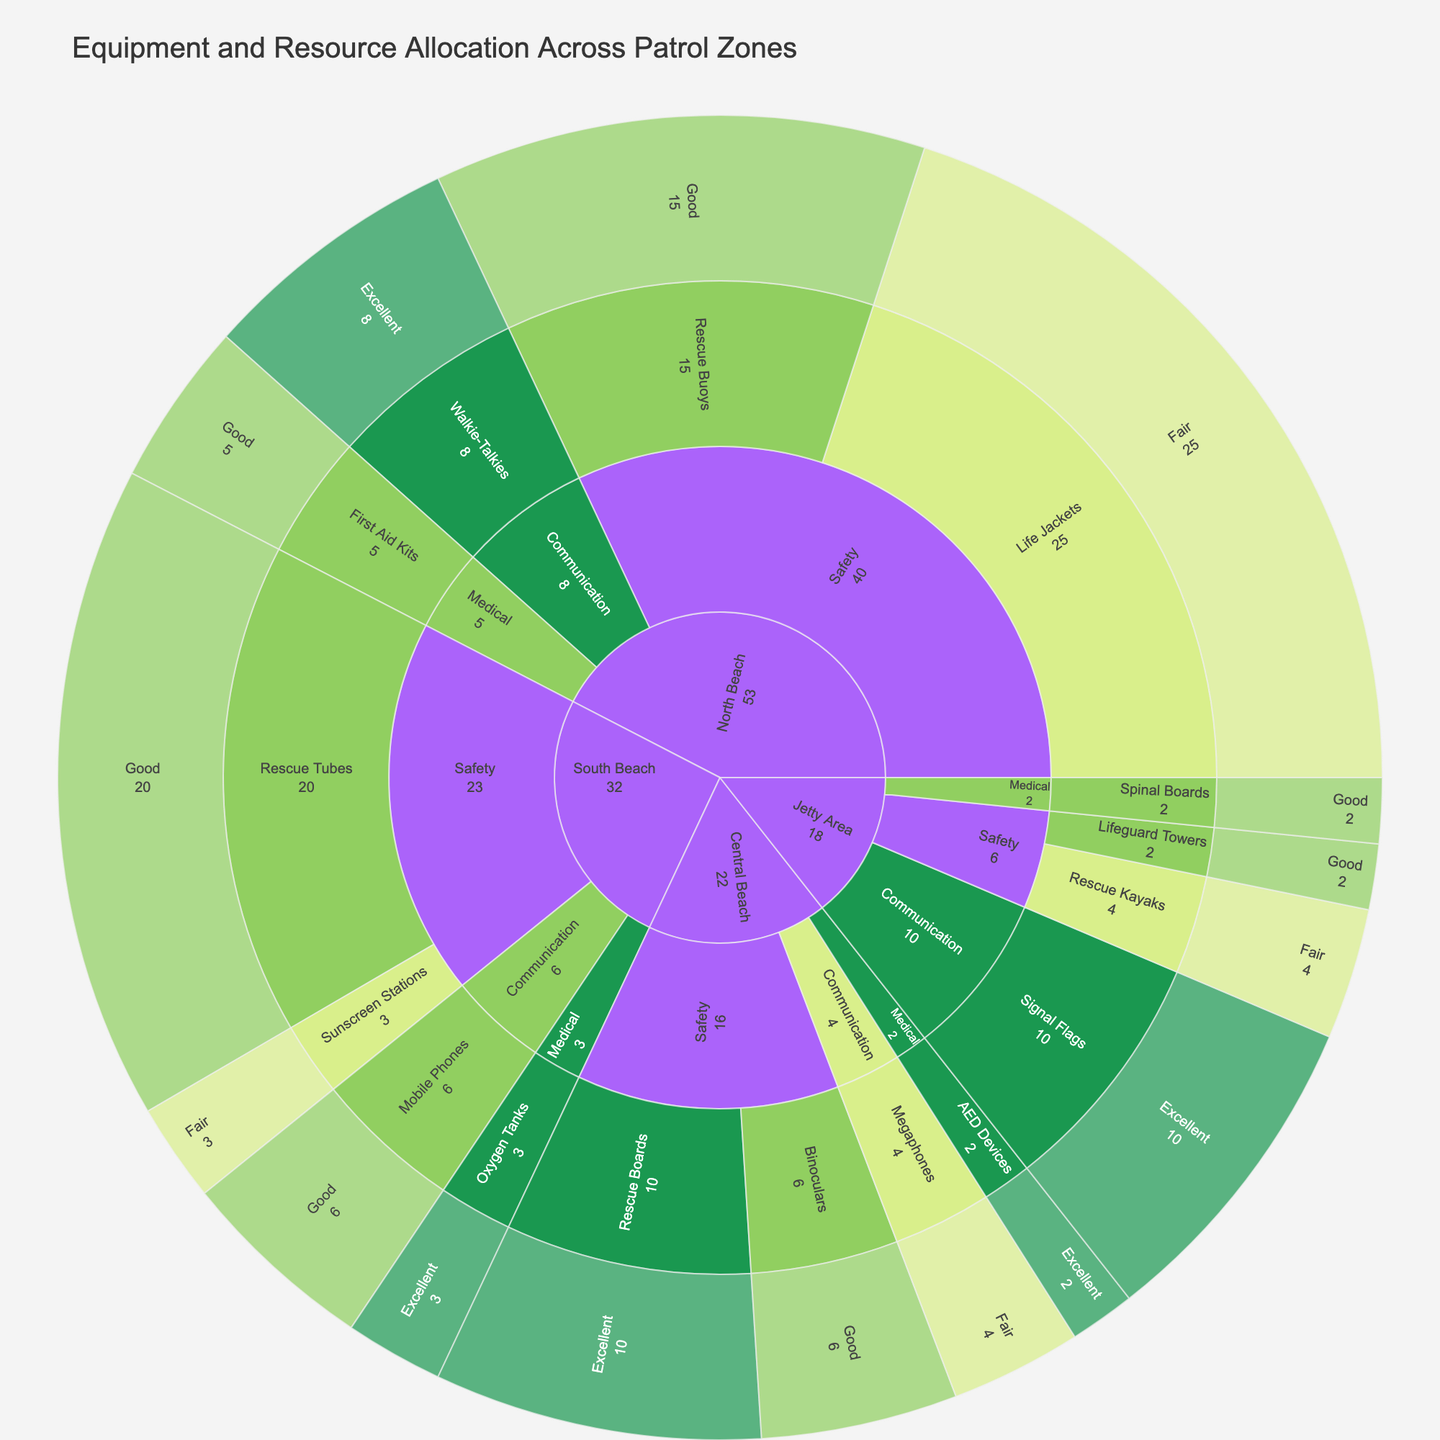What is the maintenance status of the communication equipment in the Jetty Area? To find the maintenance status of communication equipment in the Jetty Area, locate the Jetty Area in the sunburst plot, then drill down into the communication equipment segment. The plot should show signal flags with an excellent status.
Answer: Excellent Which patrol zone has the highest quantity of safety equipment? Look at each zone's safety equipment quantity visually represented by the size in the sunburst plot. The South Beach appears to have the largest quantity, summing up the safety equipment to confirm this.
Answer: South Beach How many total items are in fair maintenance status across all zones? Check each segment labeled "Fair" for every zone and item type, sum the quantities: Life Jackets (25) + Megaphones (4) + Sunscreen Stations (3) + Rescue Kayaks (4). Sum: 25 + 4 + 3 + 4.
Answer: 36 Compare the quantity of medical equipment between North Beach and Central Beach. Which has more and by how much? Locate medical equipment quantities in both zones: North Beach has First Aid Kits (5), Central Beach has AED Devices (2). Subtract the smaller total from the larger total: 5 - 2.
Answer: North Beach, by 3 What safety equipment in Central Beach is in the best maintenance condition? Identify safety equipment in Central Beach and look at their maintenance status: Rescue Boards (Excellent), Binoculars (Good). The best condition is "Excellent" for Rescue Boards.
Answer: Rescue Boards How many items in good maintenance status are there in the North Beach zone? Locate the North Beach zone, find all items labeled "Good" and sum their quantities: Rescue Buoys (15) + First Aid Kits (5). Sum: 15 + 5.
Answer: 20 What is the total number of communication items across all zones? Identify all communication items in each zone and sum their quantities: Walkie-Talkies (8) + Megaphones (4) + Mobile Phones (6) + Signal Flags (10). Sum: 8 + 4 + 6 + 10.
Answer: 28 